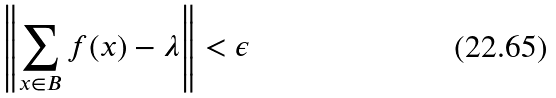Convert formula to latex. <formula><loc_0><loc_0><loc_500><loc_500>\left \| \sum _ { x \in B } f ( x ) - \lambda \right \| < \epsilon</formula> 